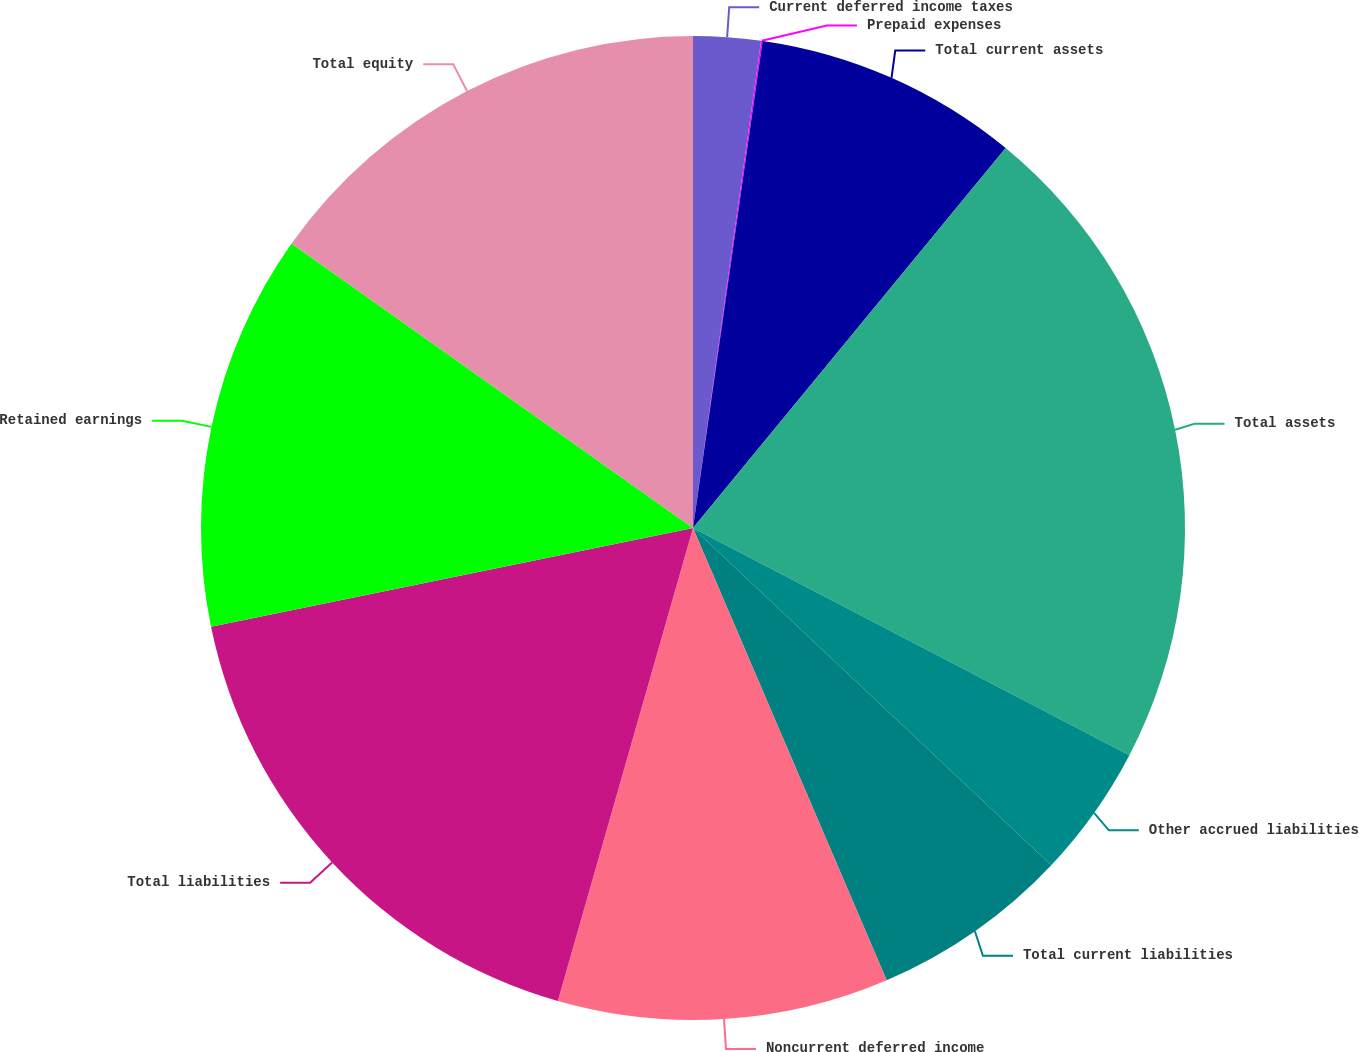<chart> <loc_0><loc_0><loc_500><loc_500><pie_chart><fcel>Current deferred income taxes<fcel>Prepaid expenses<fcel>Total current assets<fcel>Total assets<fcel>Other accrued liabilities<fcel>Total current liabilities<fcel>Noncurrent deferred income<fcel>Total liabilities<fcel>Retained earnings<fcel>Total equity<nl><fcel>2.21%<fcel>0.05%<fcel>8.7%<fcel>21.68%<fcel>4.38%<fcel>6.54%<fcel>10.87%<fcel>17.35%<fcel>13.03%<fcel>15.19%<nl></chart> 